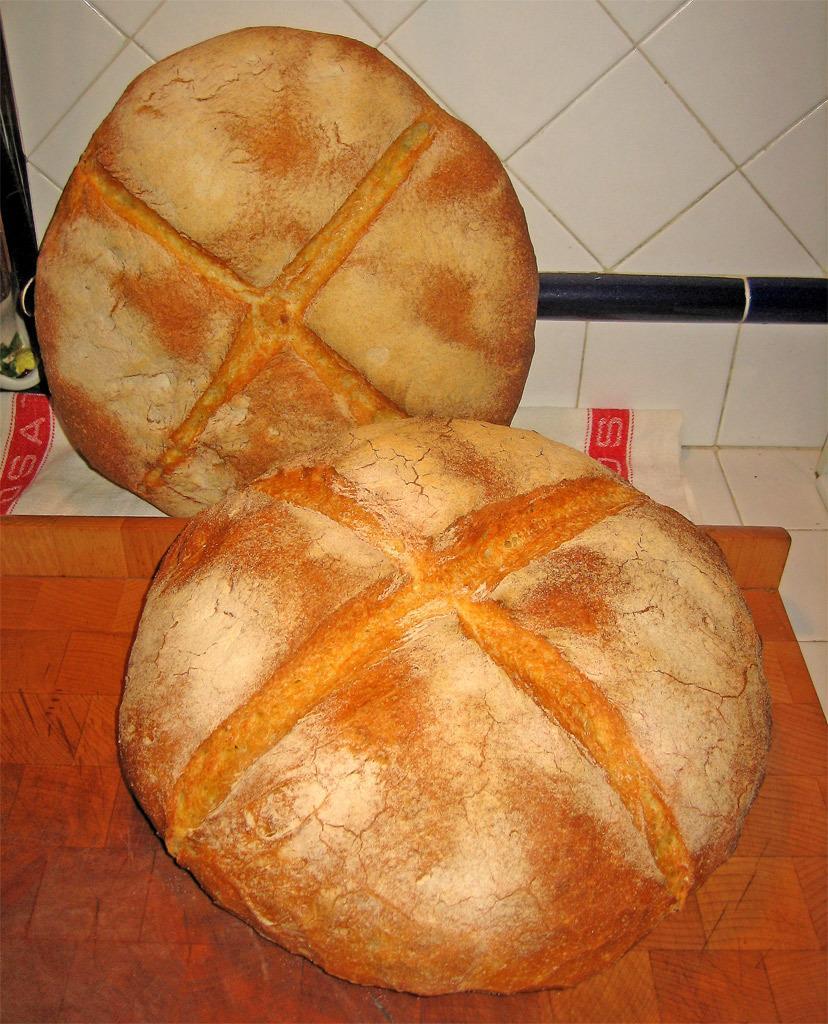Please provide a concise description of this image. In the image we can see some fruits on a table. Behind the fruits there is wall. 